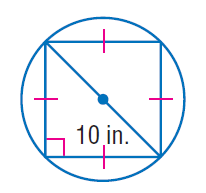Answer the mathemtical geometry problem and directly provide the correct option letter.
Question: Find the exact circumference of the circle.
Choices: A: 10 B: 25 C: 10 \pi D: 10 \pi \sqrt { 2 } D 